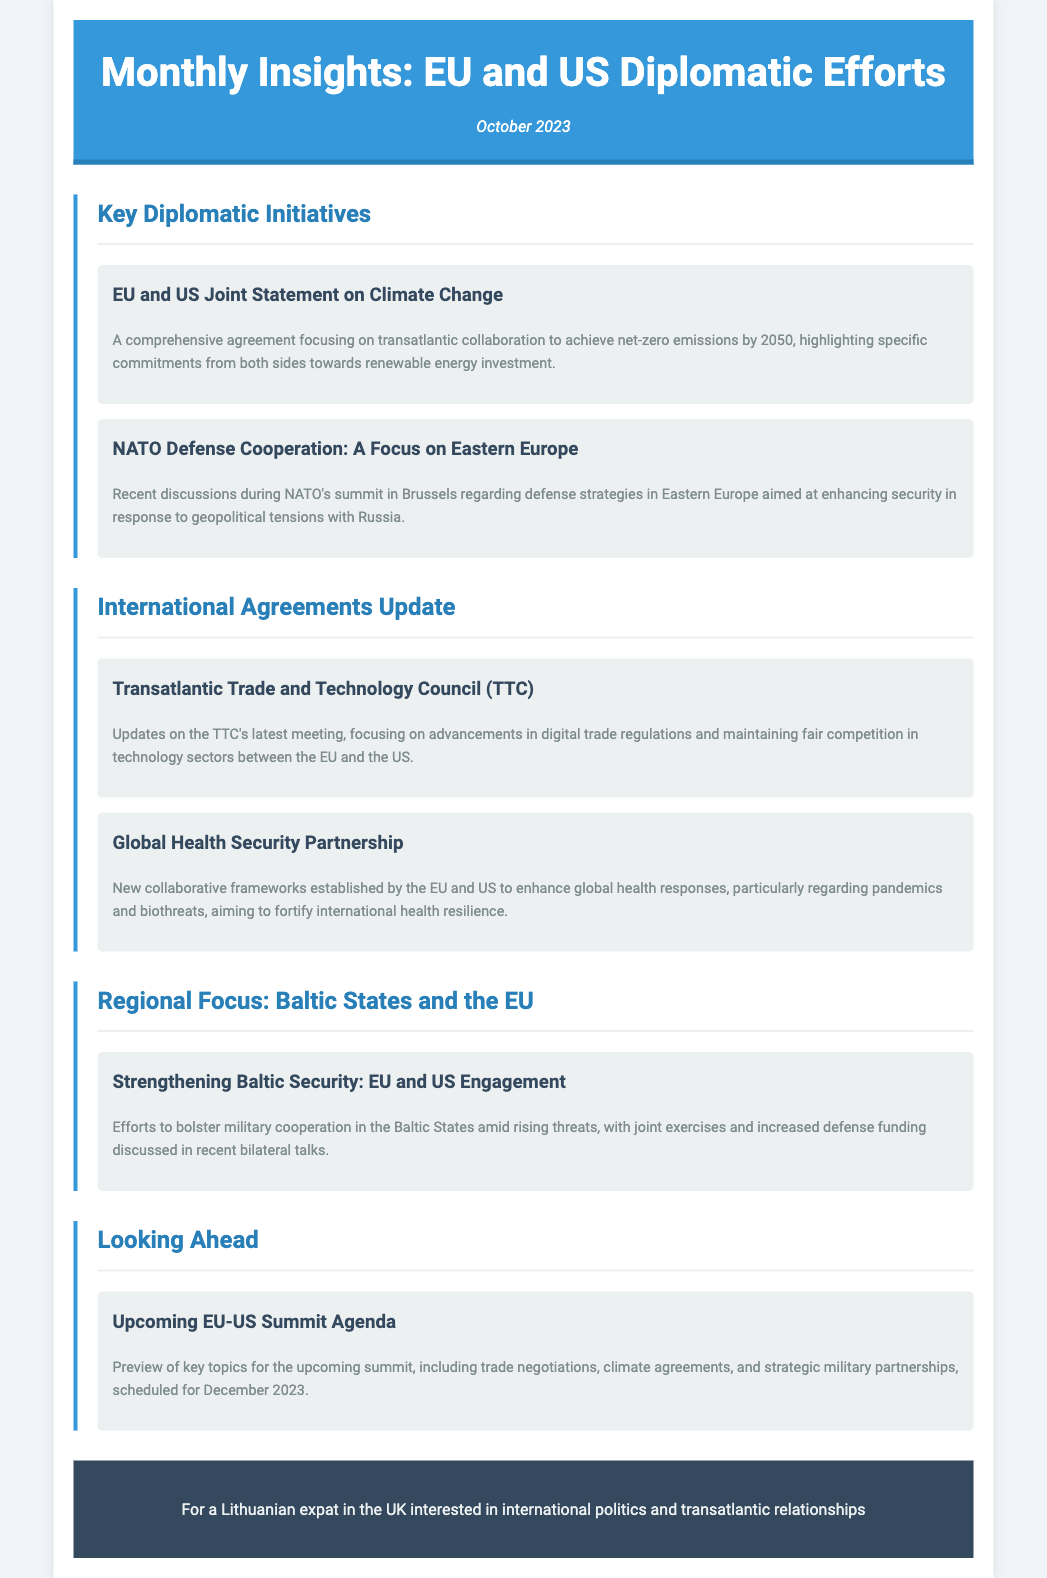What is the title of this newsletter? The title of the newsletter is presented prominently at the top of the document.
Answer: Monthly Insights: EU and US Diplomatic Efforts What is the date of this newsletter? The date is specified just below the title in italics.
Answer: October 2023 What are the two key topics covered in the "Key Diplomatic Initiatives" section? The document lists two articles under this section.
Answer: Climate Change and Eastern Europe What does the Transatlantic Trade and Technology Council focus on? The summary provides insight into the main focus areas of the TTC.
Answer: Digital trade regulations What upcoming event is mentioned in the newsletter? The "Looking Ahead" section previews an event that will be held soon.
Answer: EU-US Summit How many articles are there under the "International Agreements Update" section? This section lists two articles.
Answer: Two What is the purpose of the Global Health Security Partnership? The summary outlines the main aim of this partnership.
Answer: Enhance global health responses Which region is highlighted in the "Regional Focus" section? The section title indicates the specific geographic area of focus.
Answer: Baltic States What is the planned date for the upcoming EU-US Summit? The document states the timeline for the event.
Answer: December 2023 